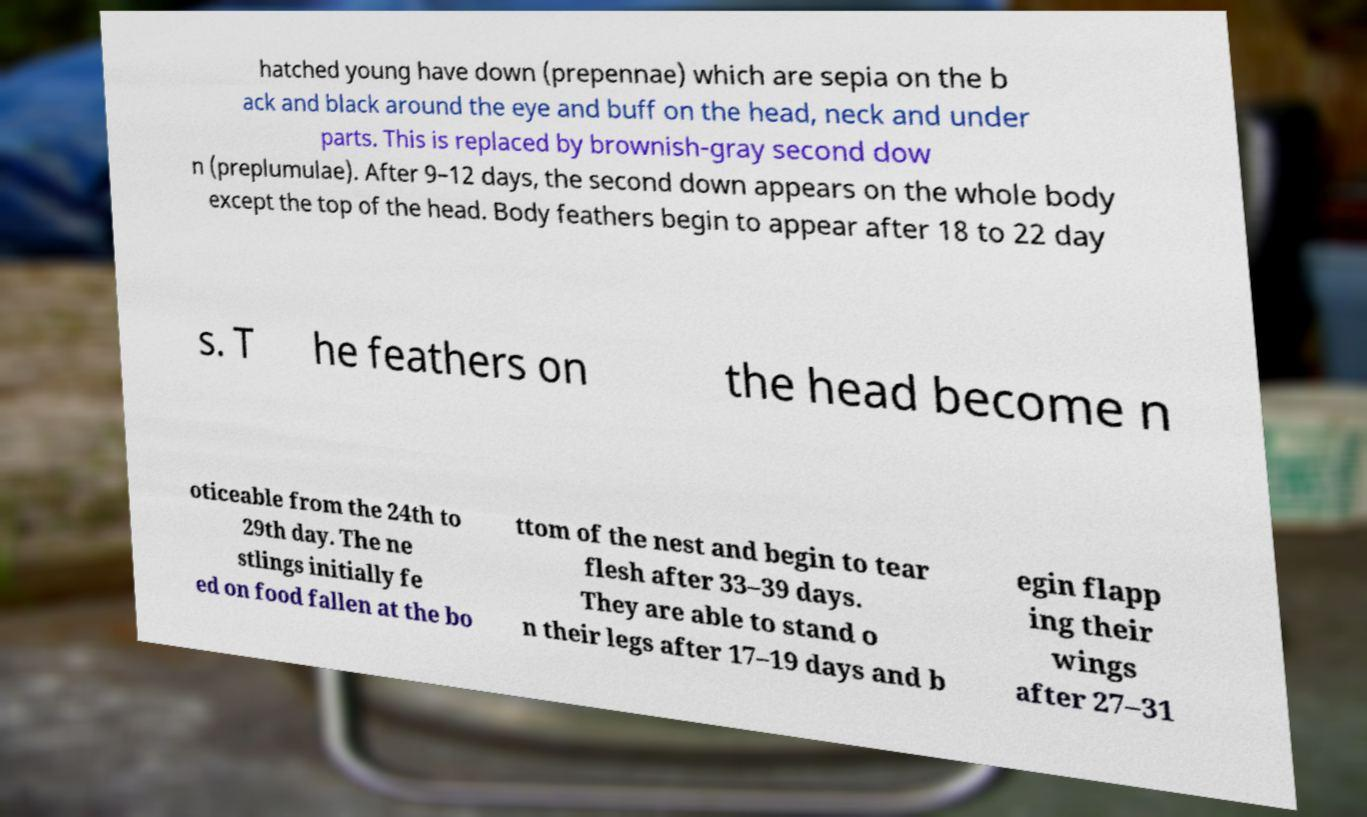Please identify and transcribe the text found in this image. hatched young have down (prepennae) which are sepia on the b ack and black around the eye and buff on the head, neck and under parts. This is replaced by brownish-gray second dow n (preplumulae). After 9–12 days, the second down appears on the whole body except the top of the head. Body feathers begin to appear after 18 to 22 day s. T he feathers on the head become n oticeable from the 24th to 29th day. The ne stlings initially fe ed on food fallen at the bo ttom of the nest and begin to tear flesh after 33–39 days. They are able to stand o n their legs after 17–19 days and b egin flapp ing their wings after 27–31 